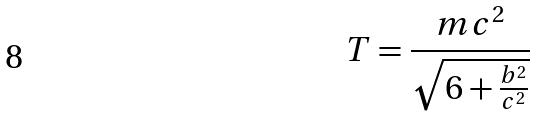Convert formula to latex. <formula><loc_0><loc_0><loc_500><loc_500>T = \frac { m c ^ { 2 } } { \sqrt { 6 + \frac { b ^ { 2 } } { c ^ { 2 } } } }</formula> 